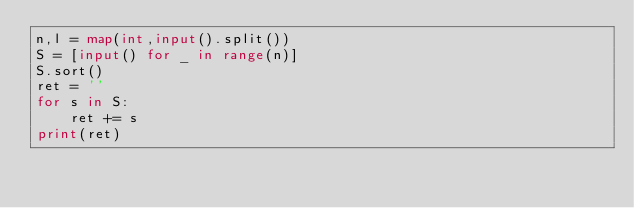Convert code to text. <code><loc_0><loc_0><loc_500><loc_500><_Python_>n,l = map(int,input().split())
S = [input() for _ in range(n)]
S.sort()
ret = ''
for s in S:
    ret += s
print(ret)</code> 